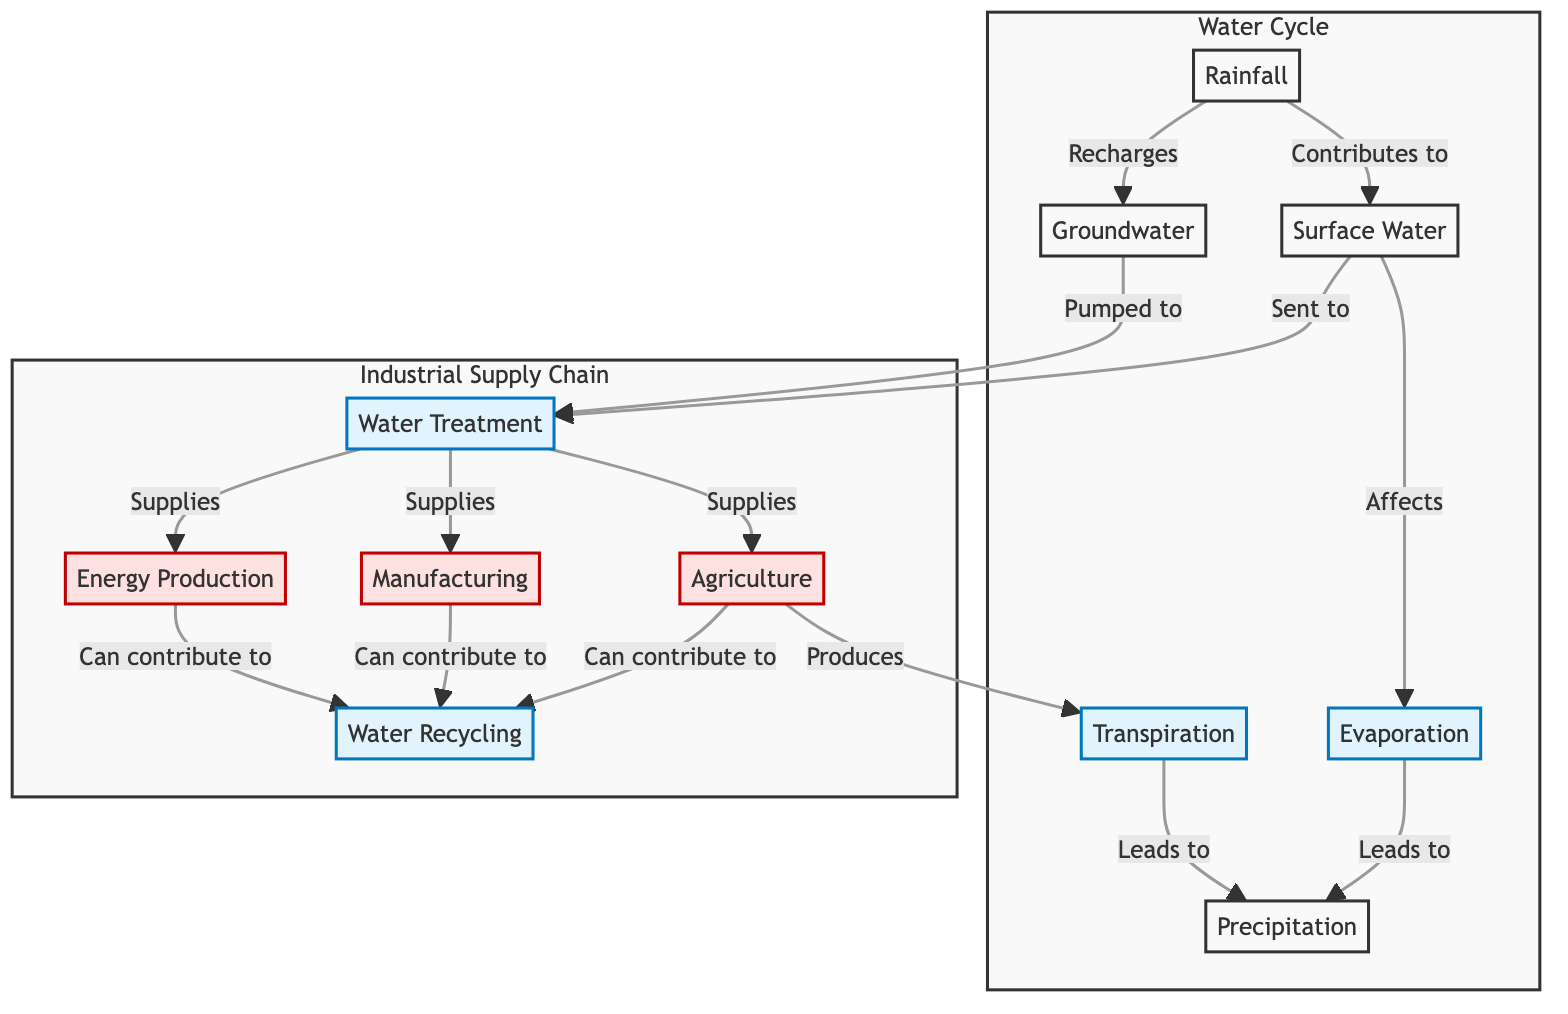What is the starting point of the water cycle in this diagram? The diagram indicates that the starting point of the water cycle is "Rainfall." This is shown as the first node, which contributes to both surface water and groundwater.
Answer: Rainfall How many major industries are highlighted in the diagram? The diagram illustrates three major industries: Agriculture, Manufacturing, and Energy Production. These are distinguished by the industry classification in the diagram.
Answer: Three What does surface water affect in the water cycle? According to the diagram, surface water directly affects "Evaporation." This relationship is shown by an arrow pointing from surface water to evaporation.
Answer: Evaporation Which processes lead to precipitation in the water cycle? The diagram shows that both "Evaporation" and "Transpiration" lead to "Precipitation." This is indicated by arrows from both processes pointing to the precipitation node, demonstrating their contribution to it.
Answer: Evaporation and Transpiration How does water treatment contribute to industrial activities? The diagram illustrates that "Water Treatment" supplies "Agriculture," "Manufacturing," and "Energy Production." This shows the vital role of water treatment in providing necessary resources for these industries.
Answer: Agriculture, Manufacturing, Energy Production What is the relationship between agriculture and water recycling? The diagram highlights that agriculture "Can contribute to" water recycling. This means that practices or outputs from agriculture can be involved in recycling water for various uses.
Answer: Can contribute to Which node represents the process that recharges groundwater? The diagram states that "Rainfall" is the node that "Recharges" groundwater, connecting these two components in the water cycle. This connection indicates how rainfall contributes to the replenishment of groundwater reserves.
Answer: Rainfall How do industries contribute back to water management practices? The diagram specifies that "Agriculture," "Manufacturing," and "Energy Production" can all contribute to "Water Recycling." This shows a flow from these industries back into the water management system, emphasizing a cycle of resource use and sustainability.
Answer: Water Recycling 